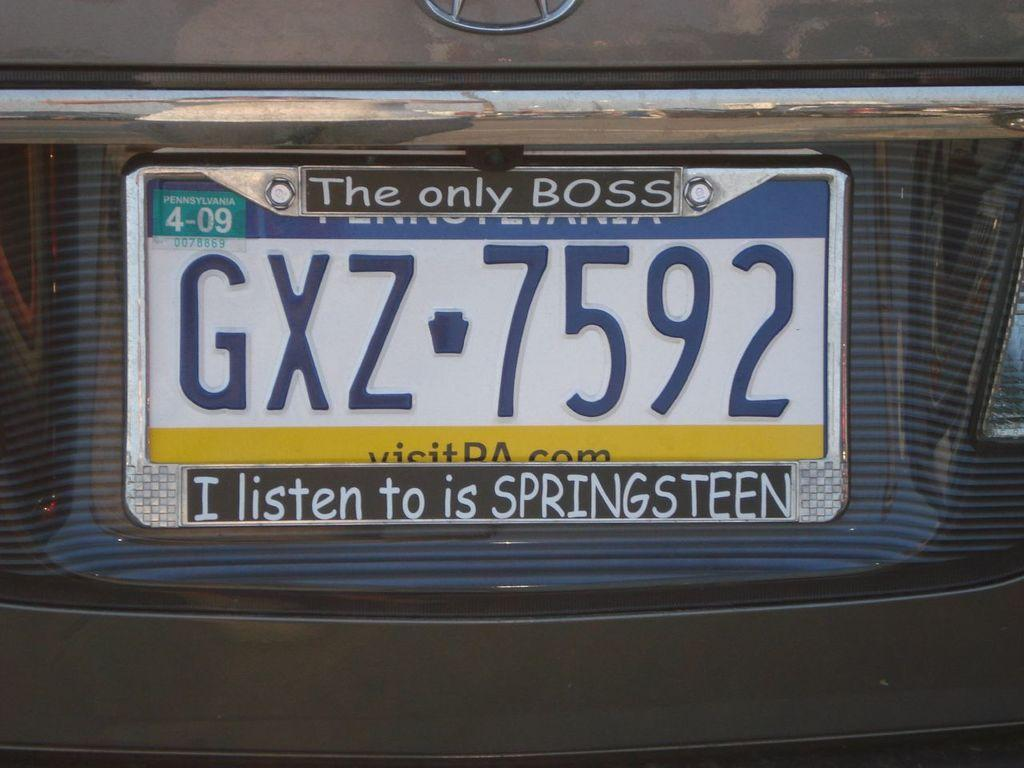What can be seen on the vehicle in the image? There is a number plate of a vehicle in the image. What else is visible in the image besides the number plate? There is some text visible in the image. Can you describe the logo at the top of the image? Yes, there is a logo at the top of the image. What type of dinner is being served in the image? There is no dinner present in the image; it only features a number plate, text, and a logo. What type of destruction can be seen in the image? There is no destruction present in the image; it is a static image of a number plate, text, and a logo. 